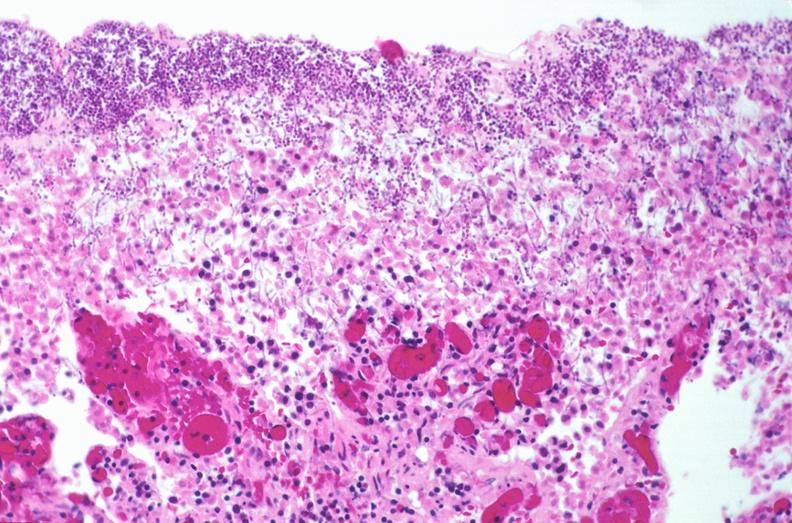s atrophy secondary to pituitectomy present?
Answer the question using a single word or phrase. No 